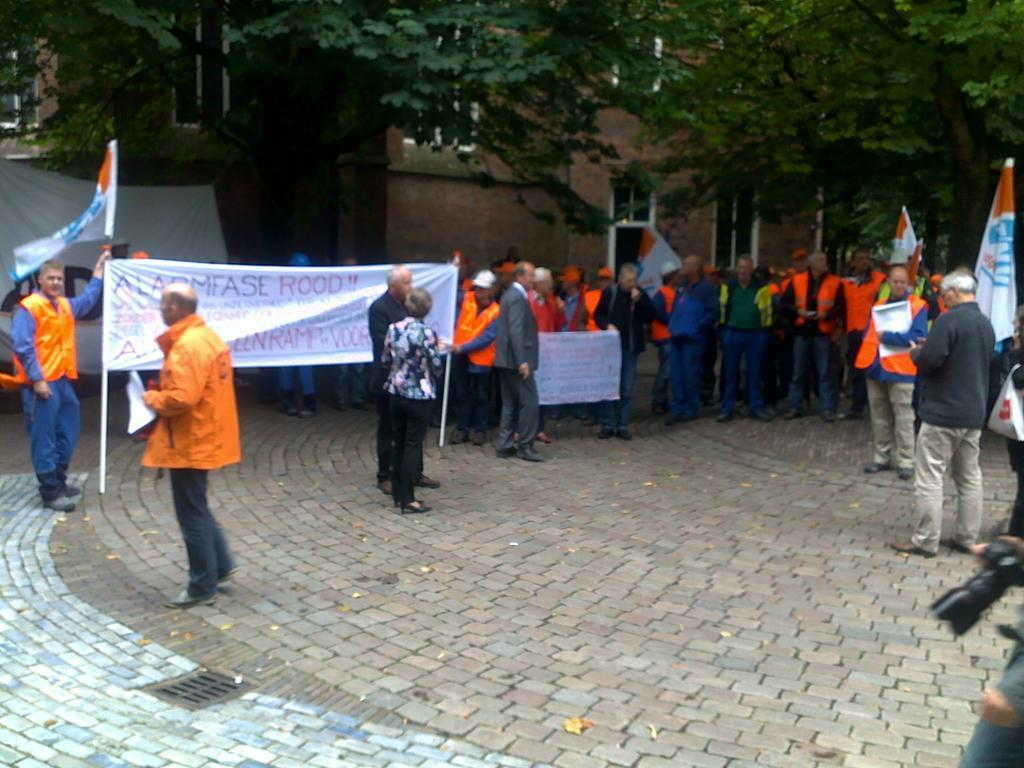What is happening on the left side of the image? Two members are holding a flex on the left side. Can you describe the people in the image? There are people standing on the land in the image. What can be seen in the background of the image? There are trees and a building in the background of the image. Can you see a fan blowing in the image? There is no fan visible in the image. Is there a sea visible in the background of the image? No, there is no sea present in the image; only trees and a building can be seen in the background. 